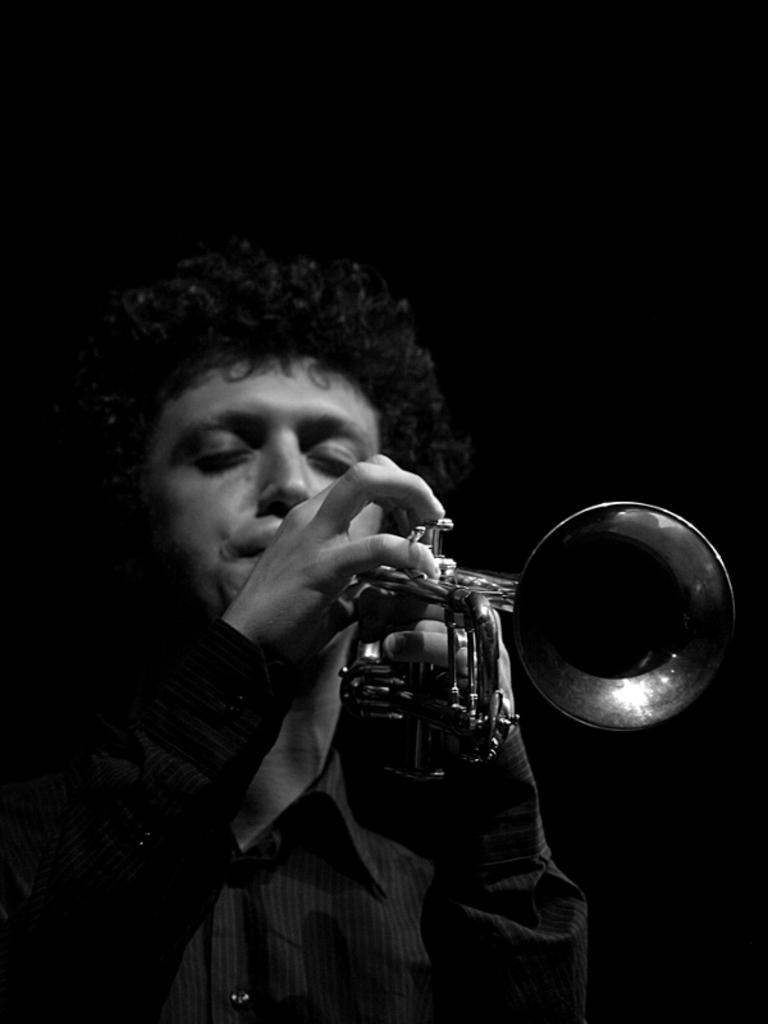Please provide a concise description of this image. In this picture we can see a man, he is playing a trumpet. 